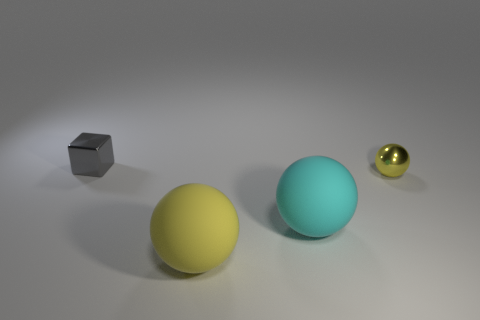Are there any other gray metallic cubes of the same size as the gray cube? no 